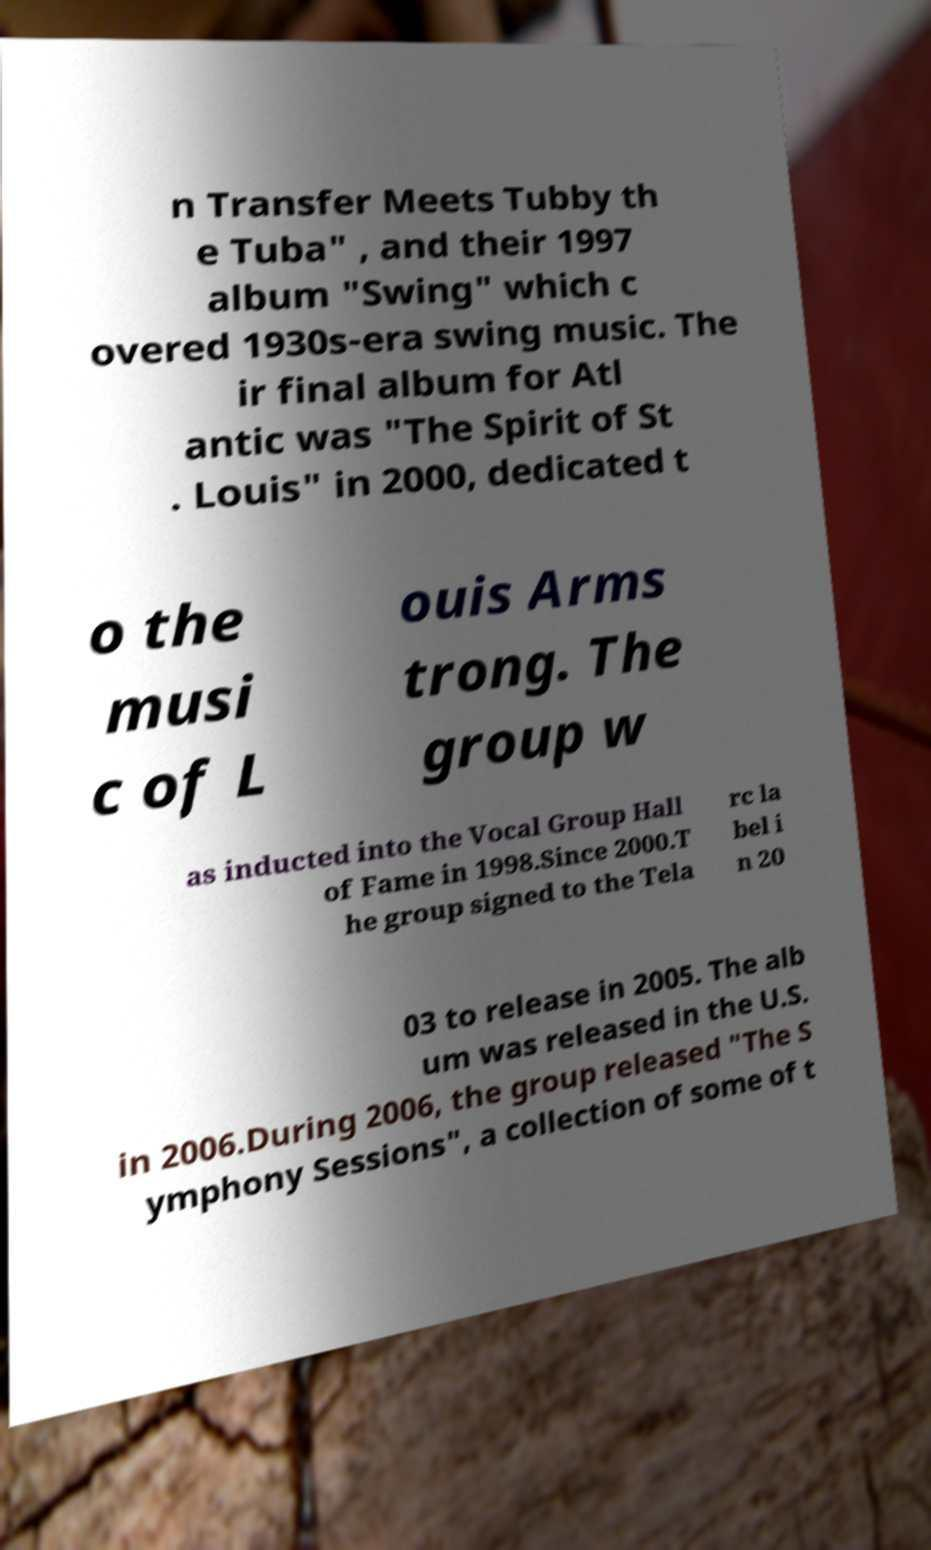Can you read and provide the text displayed in the image?This photo seems to have some interesting text. Can you extract and type it out for me? n Transfer Meets Tubby th e Tuba" , and their 1997 album "Swing" which c overed 1930s-era swing music. The ir final album for Atl antic was "The Spirit of St . Louis" in 2000, dedicated t o the musi c of L ouis Arms trong. The group w as inducted into the Vocal Group Hall of Fame in 1998.Since 2000.T he group signed to the Tela rc la bel i n 20 03 to release in 2005. The alb um was released in the U.S. in 2006.During 2006, the group released "The S ymphony Sessions", a collection of some of t 